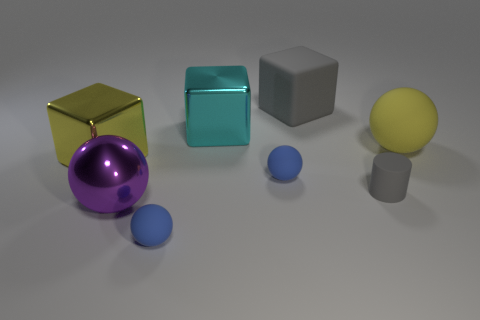Is the size of the matte cube the same as the rubber cylinder?
Offer a very short reply. No. What number of things are either blue metallic cylinders or big objects on the left side of the large gray cube?
Your answer should be compact. 3. Are there any large metal balls that are in front of the metallic thing that is behind the yellow metallic block?
Give a very brief answer. Yes. There is a tiny object that is to the right of the large matte thing left of the gray thing that is in front of the yellow cube; what is its shape?
Your answer should be compact. Cylinder. There is a large metal thing that is both behind the tiny gray rubber cylinder and in front of the cyan shiny block; what color is it?
Offer a terse response. Yellow. The metal thing in front of the yellow metal cube has what shape?
Your answer should be very brief. Sphere. What shape is the yellow thing that is the same material as the big purple thing?
Offer a very short reply. Cube. How many shiny things are large blocks or large purple cubes?
Offer a very short reply. 2. There is a tiny rubber sphere behind the metallic thing in front of the rubber cylinder; how many small objects are in front of it?
Provide a succinct answer. 2. Do the metal object that is in front of the small gray rubber cylinder and the yellow thing that is on the left side of the large gray object have the same size?
Provide a short and direct response. Yes. 